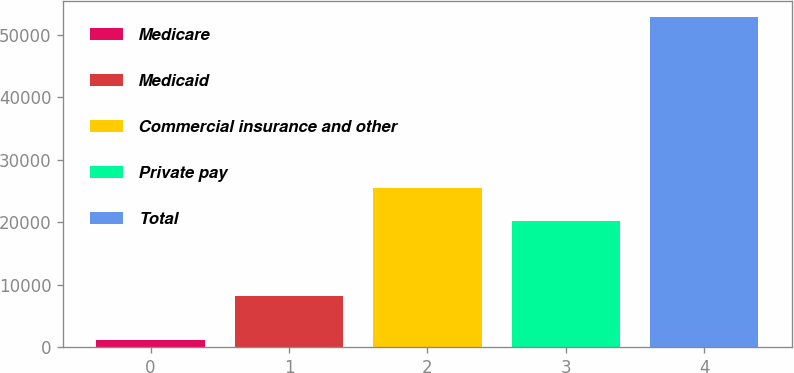<chart> <loc_0><loc_0><loc_500><loc_500><bar_chart><fcel>Medicare<fcel>Medicaid<fcel>Commercial insurance and other<fcel>Private pay<fcel>Total<nl><fcel>1128<fcel>8174<fcel>25411.1<fcel>20241<fcel>52829<nl></chart> 